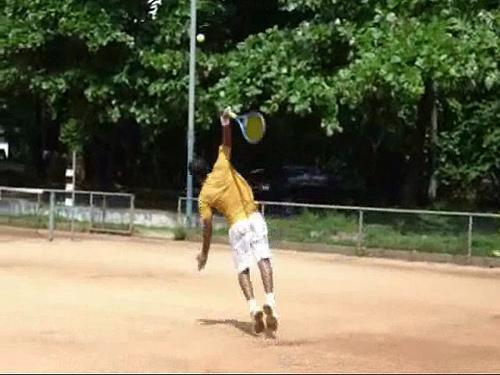The player is using all his energy when preparing to do what with the ball? Please explain your reasoning. serve it. The man's trying to serve the ball with force. 